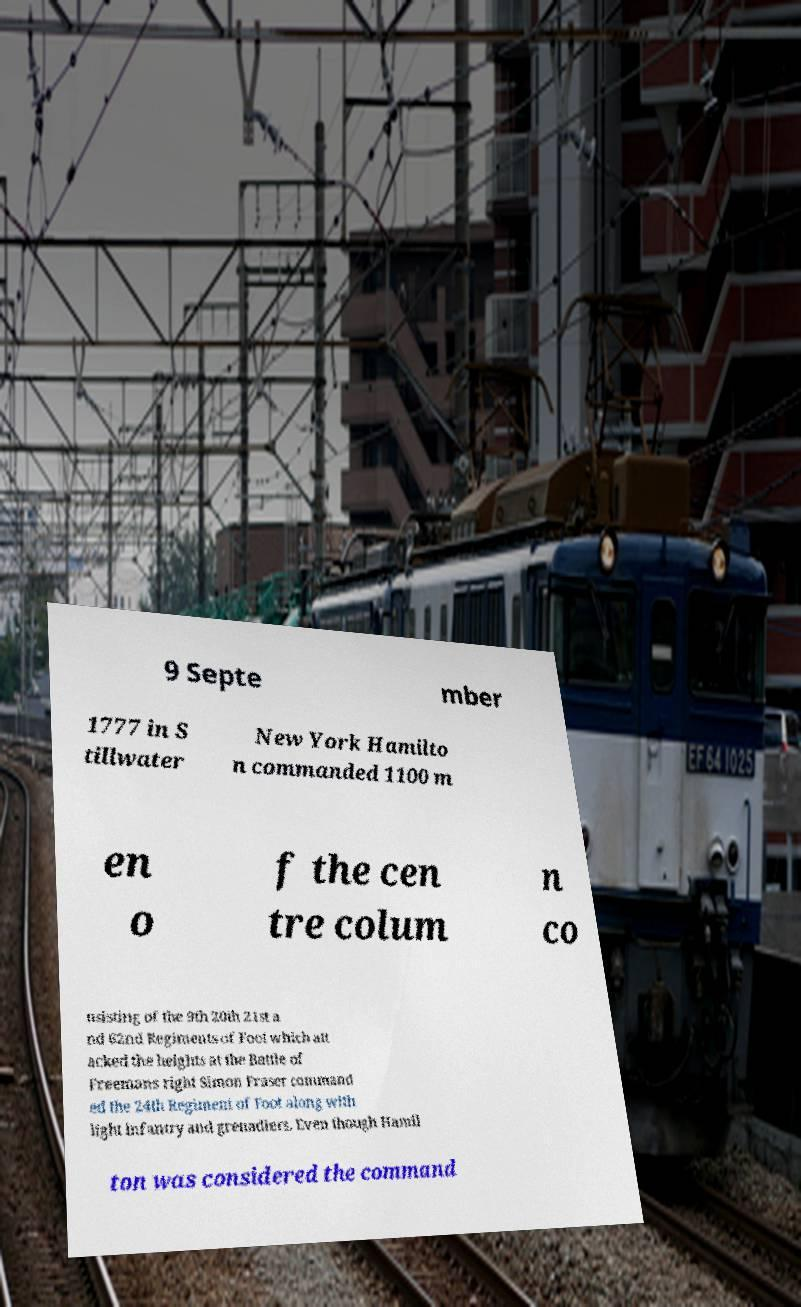Can you read and provide the text displayed in the image?This photo seems to have some interesting text. Can you extract and type it out for me? 9 Septe mber 1777 in S tillwater New York Hamilto n commanded 1100 m en o f the cen tre colum n co nsisting of the 9th 20th 21st a nd 62nd Regiments of Foot which att acked the heights at the Battle of Freemans right Simon Fraser command ed the 24th Regiment of Foot along with light infantry and grenadiers. Even though Hamil ton was considered the command 